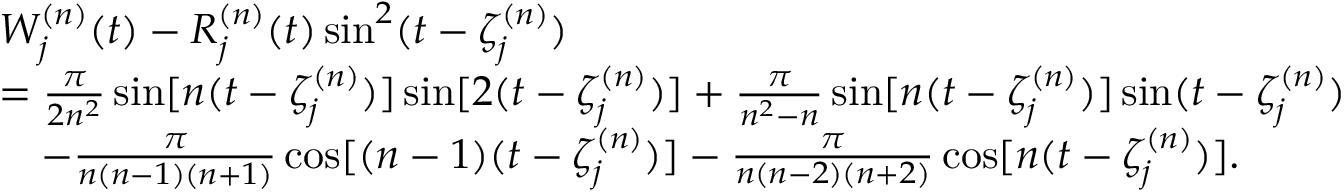<formula> <loc_0><loc_0><loc_500><loc_500>\begin{array} { r l } & { W _ { j } ^ { ( n ) } ( t ) - R _ { j } ^ { ( n ) } ( t ) \sin ^ { 2 } ( t - \zeta _ { j } ^ { ( n ) } ) } \\ & { = \frac { \pi } { 2 n ^ { 2 } } \sin [ n ( t - \zeta _ { j } ^ { ( n ) } ) ] \sin [ 2 ( t - \zeta _ { j } ^ { ( n ) } ) ] + \frac { \pi } { n ^ { 2 } - n } \sin [ n ( t - \zeta _ { j } ^ { ( n ) } ) ] \sin ( t - \zeta _ { j } ^ { ( n ) } ) } \\ & { \quad - \frac { \pi } { n ( n - 1 ) ( n + 1 ) } \cos [ ( n - 1 ) ( t - \zeta _ { j } ^ { ( n ) } ) ] - \frac { \pi } { n ( n - 2 ) ( n + 2 ) } \cos [ n ( t - \zeta _ { j } ^ { ( n ) } ) ] . } \end{array}</formula> 